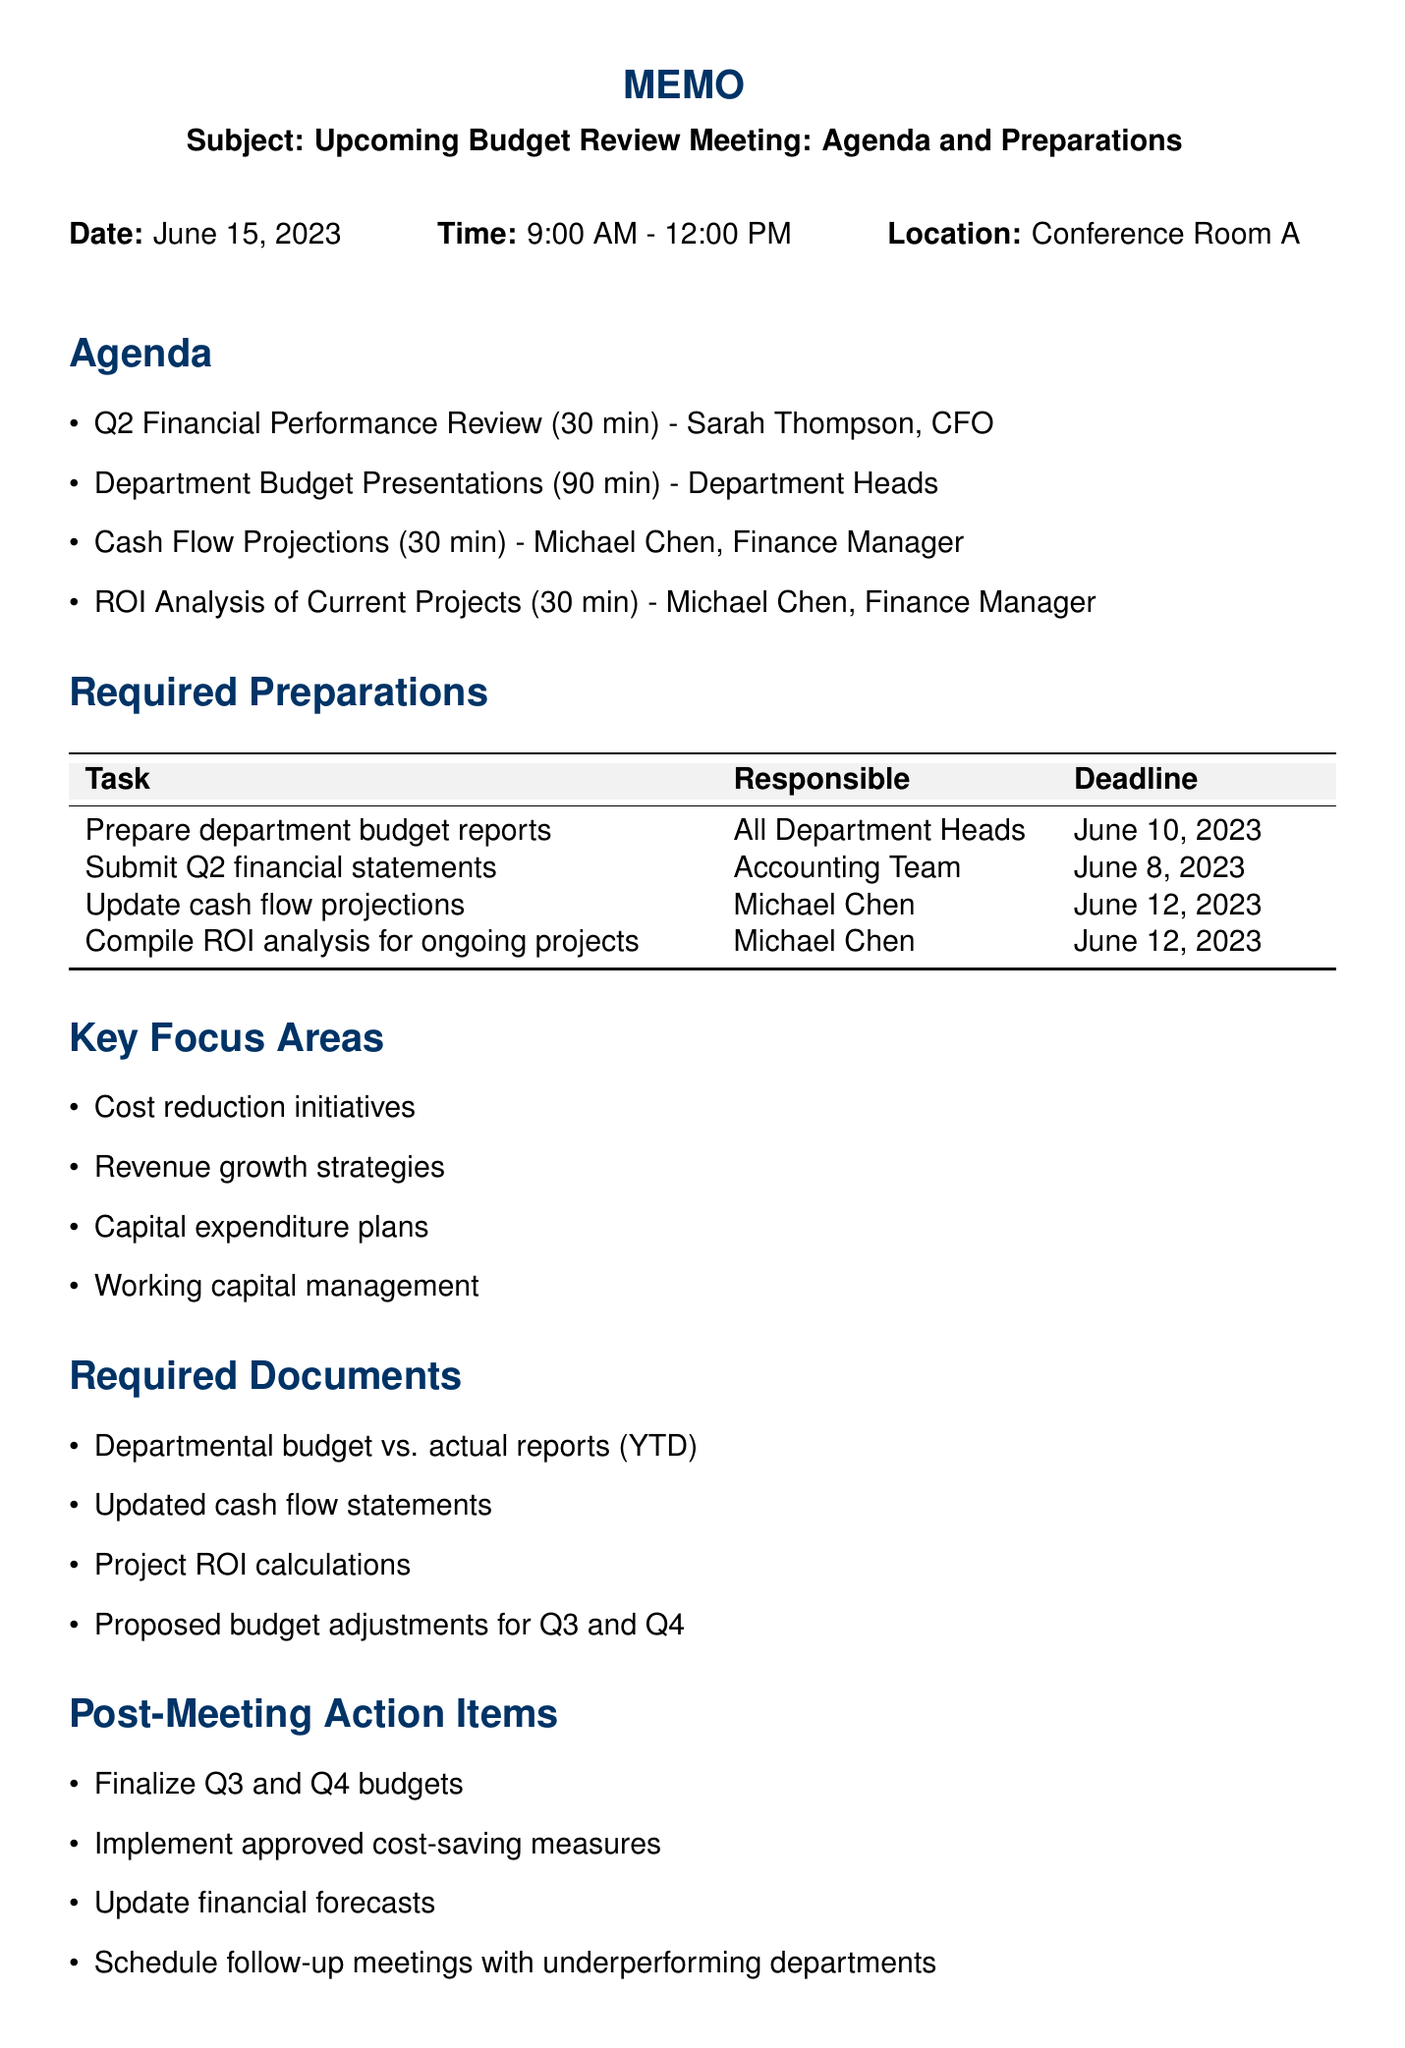What is the meeting date? The meeting date is specifically mentioned as June 15, 2023 in the document.
Answer: June 15, 2023 Who is the presenter for the Q2 Financial Performance Review? The document identifies Sarah Thompson, CFO, as the presenter for this agenda item.
Answer: Sarah Thompson, CFO How long is the Department Budget Presentations scheduled for? The duration for this agenda item is clearly stated as 90 minutes.
Answer: 90 minutes What is the deadline for submitting Q2 financial statements? The deadline for submission is outlined in the preparations section, which states it is due by June 8, 2023.
Answer: June 8, 2023 What are the key focus areas mentioned in the memo? The document lists key focus areas, which include cost reduction initiatives, revenue growth strategies, capital expenditure plans, and working capital management.
Answer: Cost reduction initiatives, Revenue growth strategies, Capital expenditure plans, Working capital management Which team is responsible for updating cash flow projections? The responsible individual for updating cash flow projections is noted as Michael Chen.
Answer: Michael Chen What are the required documents for the meeting? The memo specifies required documents such as departmental budget vs. actual reports, updated cash flow statements, project ROI calculations, and proposed budget adjustments.
Answer: Departmental budget vs. actual reports (YTD), Updated cash flow statements, Project ROI calculations, Proposed budget adjustments for Q3 and Q4 What action item is listed for post-meeting? The document includes multiple action items post-meeting, one of which is to finalize Q3 and Q4 budgets.
Answer: Finalize Q3 and Q4 budgets What additional preparation is requested from attendees? Attendees are asked to come prepared with budget variance explanations, indicating the need for specific presentation readiness.
Answer: Budget variance explanations 